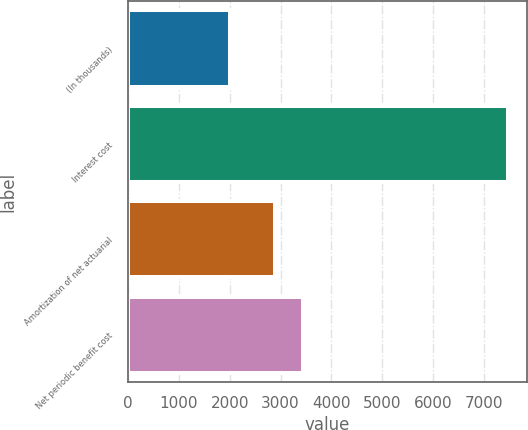Convert chart to OTSL. <chart><loc_0><loc_0><loc_500><loc_500><bar_chart><fcel>(In thousands)<fcel>Interest cost<fcel>Amortization of net actuarial<fcel>Net periodic benefit cost<nl><fcel>2014<fcel>7468<fcel>2895<fcel>3440.4<nl></chart> 